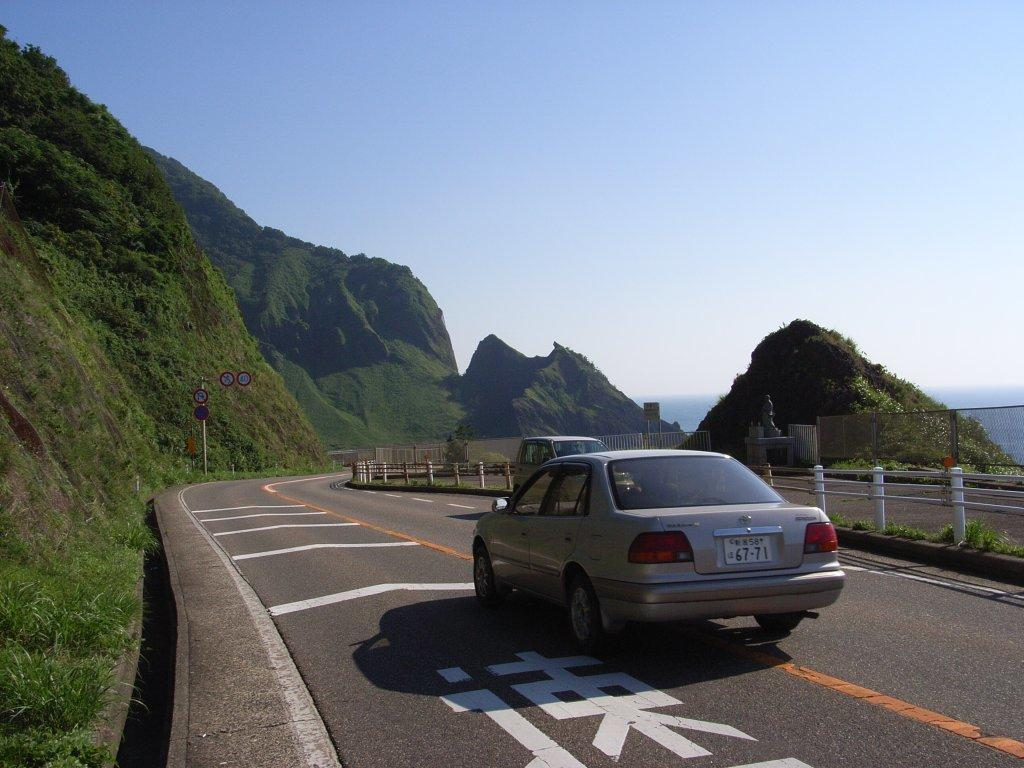What can be seen on the road in the image? There are cars on the road in the image. What type of barrier is present in the image? There is a fence in the image. What type of vegetation is visible in the image? There is grass in the image. What can be seen in the background of the image? There is a board on poles, hills, and the sky visible in the background. Can you tell me how many wrens are sitting on the wire in the image? There is no wire or wrens present in the image. What is the height of the low-hanging branch in the image? There is no branch mentioned in the provided facts, and therefore no such information can be given. 